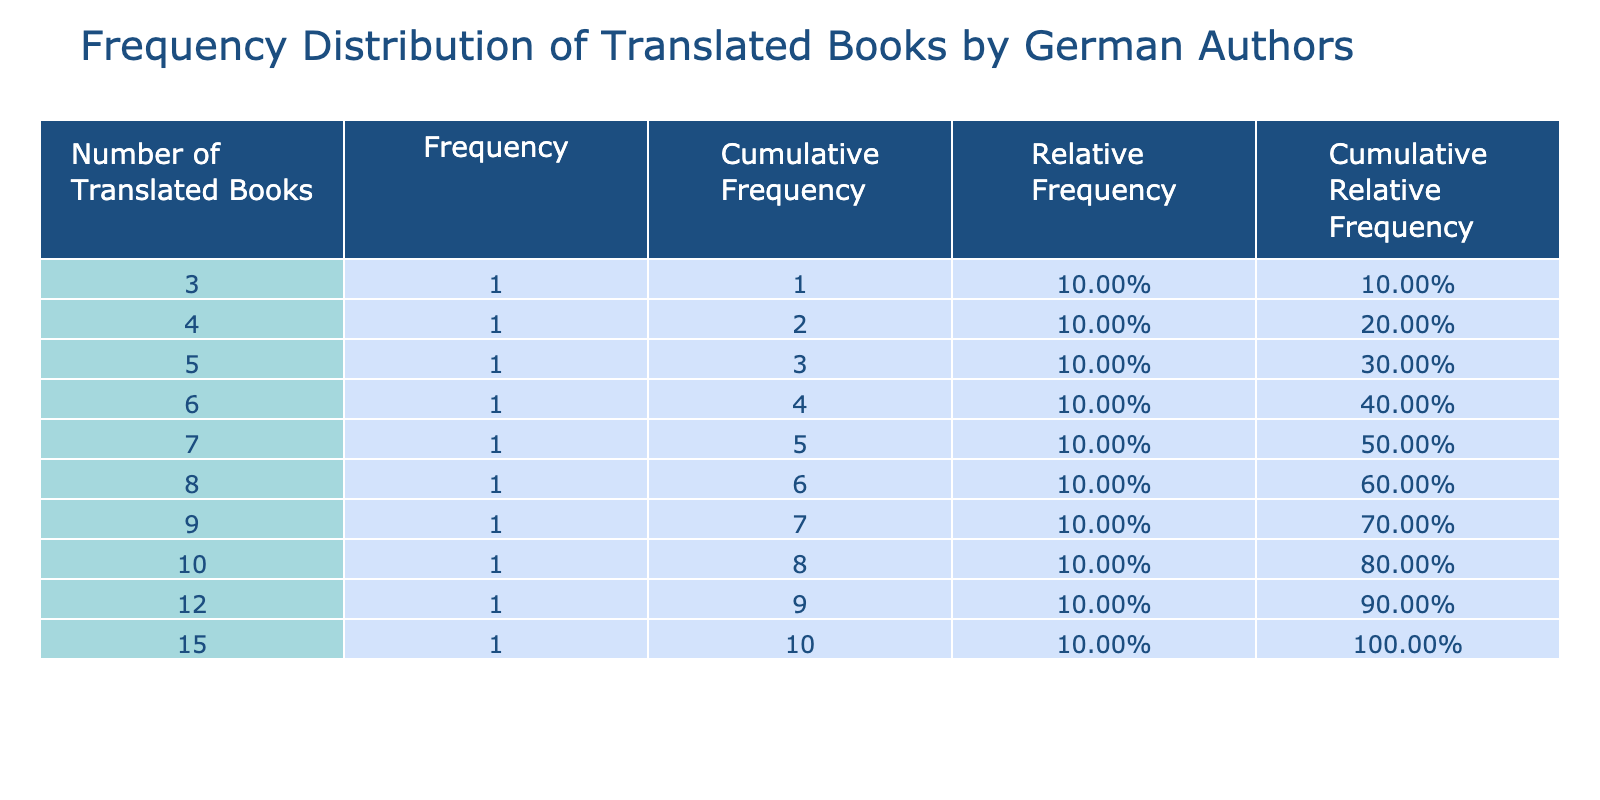What is the frequency of authors who have translated 12 books? The table lists Franz Kafka with 12 translated books, and the frequency column indicates that there is 1 author that falls into this category.
Answer: 1 How many authors have translated more than 10 books? Looking at the "Number of Translated Books" column, the authors with more than 10 translated books are Hermann Hesse (15), Franz Kafka (12), and Thomas Mann (10). This totals 3 authors.
Answer: 3 What is the cumulative frequency for authors with 8 translated books? In the table, Günter Grass is the only author with 8 translated books. The cumulative frequency adds all authors with numbers less than or equal to 8, which include 4 authors (Nelly Sachs, Max Frisch, Peter Handke, Christa Wolf, and Günter Grass). The cumulative frequency at 8 translates to 5 for these authors.
Answer: 5 Is the relative frequency of authors who have translated fewer than 6 books greater than the relative frequency of those who have translated 8 or more books? First, I find the relative frequency for authors with fewer than 6 books: Nelly Sachs (4), Max Frisch (3), and the combined relative frequency is (1/10 + 1/10 + 1/10) = 0.3 (or 30%). Then, I find the relative frequency for those with 8 or more books: Hermann Hesse, Franz Kafka, Thomas Mann, and Günter Grass, which sums to 0.4 (or 40%). Comparing these, 30% is less than 40%.
Answer: No What is the average number of translated books by the authors listed? The total number of translated books is 15 + 12 + 10 + 8 + 5 + 7 + 6 + 4 + 9 + 3 = 81. There are 10 authors, so the average is calculated by dividing the total by the number of authors: 81 / 10 = 8.1.
Answer: 8.1 How many authors have translated exactly 5 books? In the table, only Ingeborg Bachmann is listed with 5 translated books, so we can conclude there is 1 author in this category.
Answer: 1 What is the cumulative relative frequency of authors who have translated 6 or more books? To calculate this, I first need the cumulative relative frequencies for the numbers of translated books above 6, which includes Hermann Hesse (15), Franz Kafka (12), Thomas Mann (10), Günter Grass (8), and Christa Wolf (7). The cumulative relative frequencies up to and including 8 combine to 0.7 (or 70%). Hence, the cumulative relative frequency of those with 6 or more books is total of 6 authors: 0.8 (80%).
Answer: 0.8 What percentage of authors have translated less than 5 books? Only Max Frisch (3) has fewer than 5 translated books. Therefore, the relative frequency for this case is 1 out of 10 authors, giving a percentage of 10%.
Answer: 10% 